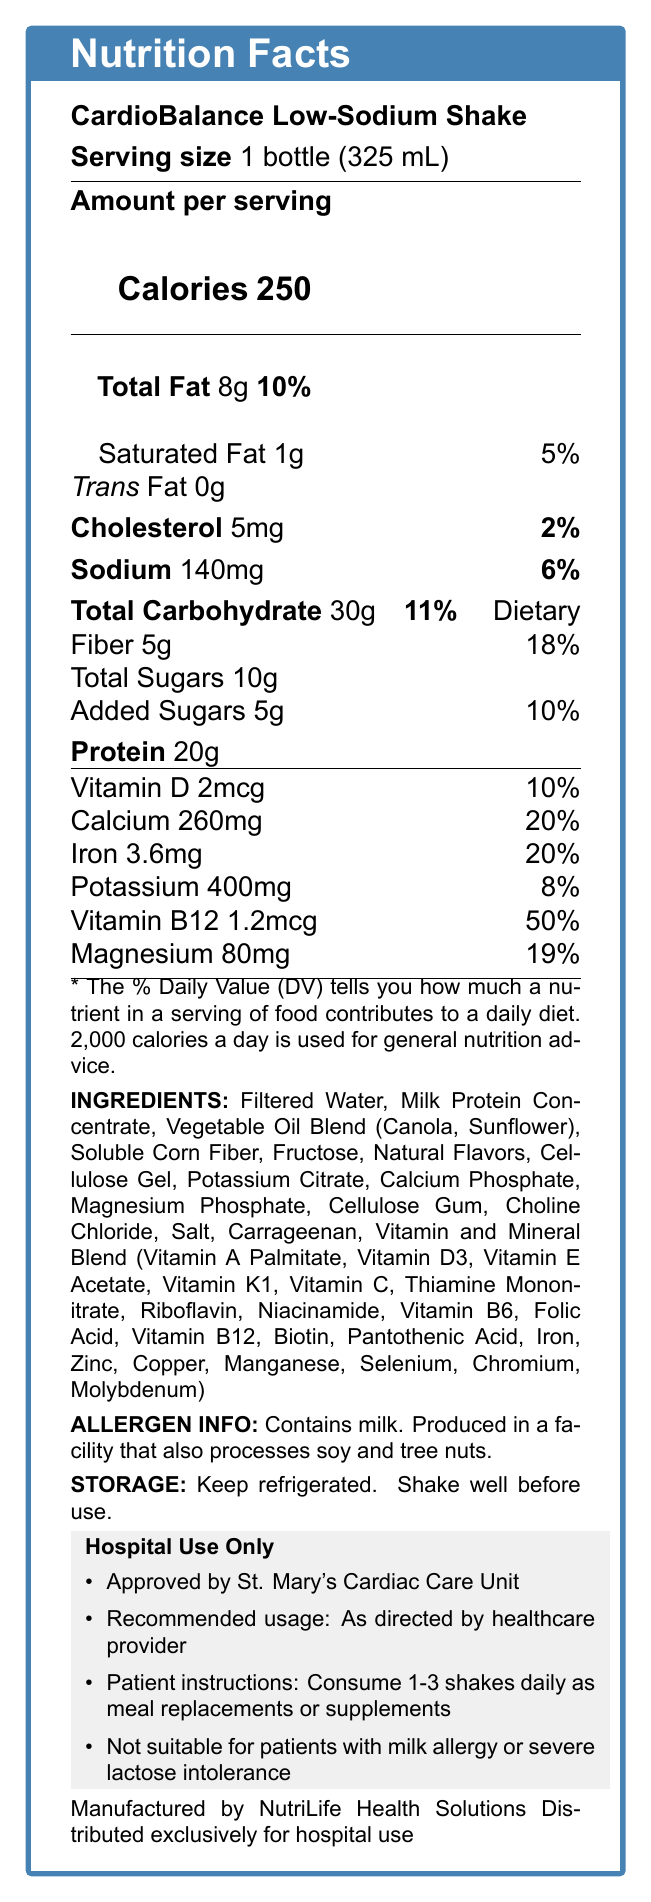What is the product name? The product name is listed at the top of the Nutrition Facts box.
Answer: CardioBalance Low-Sodium Shake What is the serving size for CardioBalance Low-Sodium Shake? The serving size is mentioned right below the product name and title "Serving size."
Answer: 1 bottle (325 mL) How much protein does one serving of the shake contain? The protein amount is located under the "Amount per serving" section.
Answer: 20g What percentage of daily value for sodium does one serving provide? The daily value percentage for sodium is listed next to the sodium amount under the "Amount per serving" section.
Answer: 6% What is the main contraindication mentioned for this product? This is listed under the hospital use instructions in the highlighted box.
Answer: Not suitable for patients with milk allergy or severe lactose intolerance What are the sugars content in one serving? A. 5g B. 10g C. 15g D. 20g The total sugars content is listed under the Total Carbohydrate section, noting 10g.
Answer: B. 10g Which vitamin has the highest daily value percentage in this product? A. Vitamin D B. Calcium C. Vitamin B12 D. Magnesium Vitamin B12 has a daily value percentage of 50%, the highest among the listed vitamins and minerals.
Answer: C. Vitamin B12 Does the product contain any allergens? The allergen information is provided, indicating that the product contains milk and is produced in a facility that also processes soy and tree nuts.
Answer: Yes Summarize the main idea of the document. The document aims to inform healthcare providers about the shake's nutritional profile, health benefits, usage instructions, and suitability for patients with specific dietary needs.
Answer: The document provides detailed nutrition information for the CardioBalance Low-Sodium Shake, a meal replacement shake designed for cardiac patients. It highlights the product benefits, nutritional content per serving, allergen information, storage instructions, and specific recommendations and contraindications for hospital use. What is the total amount of fat in one serving? The total fat content is listed under "Total Fat" in the "Amount per serving" section.
Answer: 8g Who manufactures the CardioBalance Low-Sodium Shake? The manufacturer's name is stated at the bottom of the document.
Answer: NutriLife Health Solutions What is the daily value percentage for dietary fiber? The daily value percentage for dietary fiber is listed next to the dietary fiber amount under Total Carbohydrate.
Answer: 18% Where should the product be stored? The storage instructions specify to keep the product refrigerated.
Answer: Keep refrigerated How is the shake distributed? The distribution information is provided at the bottom of the document.
Answer: Exclusively for hospital use Is the product suitable for vegans? The document does not specify if the product is vegan-friendly or only mentions certain allergens like milk.
Answer: Not enough information Which departments in a hospital would most likely use this product? A. Cardiology B. Neurology C. Nutrition Services D. Rehabilitation The potential departments listed in the sales rep notes include Cardiology, Nutrition Services, and Rehabilitation.
Answer: A, C, D How many servings are there in one container? The servings per container is noted as 1 in the nutrition facts.
Answer: 1 What is the amount of potassium in one serving, and what percentage of the daily value does this represent? The potassium content and daily value percentage are listed in the vitamins and minerals section.
Answer: 400mg, 8% Which specific hospital unit approved the product? This information is included in the hospital-specific info section.
Answer: St. Mary's Cardiac Care Unit 